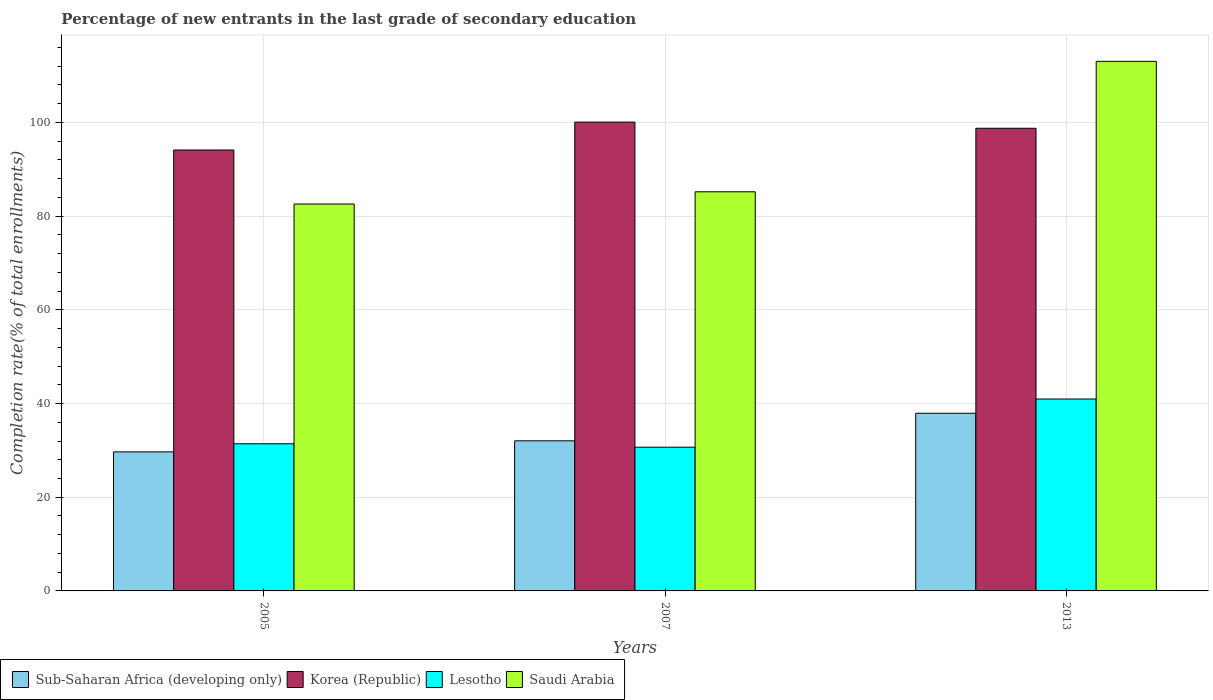Are the number of bars on each tick of the X-axis equal?
Offer a very short reply. Yes. How many bars are there on the 3rd tick from the right?
Provide a succinct answer. 4. What is the label of the 1st group of bars from the left?
Offer a terse response. 2005. In how many cases, is the number of bars for a given year not equal to the number of legend labels?
Give a very brief answer. 0. What is the percentage of new entrants in Korea (Republic) in 2013?
Offer a terse response. 98.75. Across all years, what is the maximum percentage of new entrants in Saudi Arabia?
Offer a terse response. 113.04. Across all years, what is the minimum percentage of new entrants in Korea (Republic)?
Give a very brief answer. 94.12. In which year was the percentage of new entrants in Sub-Saharan Africa (developing only) maximum?
Your response must be concise. 2013. In which year was the percentage of new entrants in Lesotho minimum?
Provide a succinct answer. 2007. What is the total percentage of new entrants in Saudi Arabia in the graph?
Your answer should be very brief. 280.83. What is the difference between the percentage of new entrants in Lesotho in 2005 and that in 2013?
Your answer should be compact. -9.56. What is the difference between the percentage of new entrants in Lesotho in 2007 and the percentage of new entrants in Korea (Republic) in 2013?
Your answer should be very brief. -68.07. What is the average percentage of new entrants in Lesotho per year?
Keep it short and to the point. 34.35. In the year 2005, what is the difference between the percentage of new entrants in Korea (Republic) and percentage of new entrants in Sub-Saharan Africa (developing only)?
Your response must be concise. 64.44. What is the ratio of the percentage of new entrants in Lesotho in 2007 to that in 2013?
Make the answer very short. 0.75. Is the percentage of new entrants in Saudi Arabia in 2007 less than that in 2013?
Offer a very short reply. Yes. What is the difference between the highest and the second highest percentage of new entrants in Sub-Saharan Africa (developing only)?
Your answer should be compact. 5.88. What is the difference between the highest and the lowest percentage of new entrants in Saudi Arabia?
Make the answer very short. 30.45. In how many years, is the percentage of new entrants in Lesotho greater than the average percentage of new entrants in Lesotho taken over all years?
Offer a terse response. 1. Is the sum of the percentage of new entrants in Sub-Saharan Africa (developing only) in 2005 and 2013 greater than the maximum percentage of new entrants in Lesotho across all years?
Ensure brevity in your answer.  Yes. Is it the case that in every year, the sum of the percentage of new entrants in Korea (Republic) and percentage of new entrants in Lesotho is greater than the sum of percentage of new entrants in Sub-Saharan Africa (developing only) and percentage of new entrants in Saudi Arabia?
Provide a short and direct response. Yes. What does the 4th bar from the right in 2013 represents?
Ensure brevity in your answer.  Sub-Saharan Africa (developing only). How many bars are there?
Your response must be concise. 12. Are all the bars in the graph horizontal?
Ensure brevity in your answer.  No. How many years are there in the graph?
Your answer should be very brief. 3. What is the difference between two consecutive major ticks on the Y-axis?
Offer a very short reply. 20. Are the values on the major ticks of Y-axis written in scientific E-notation?
Offer a terse response. No. Does the graph contain grids?
Ensure brevity in your answer.  Yes. Where does the legend appear in the graph?
Provide a succinct answer. Bottom left. What is the title of the graph?
Your answer should be compact. Percentage of new entrants in the last grade of secondary education. What is the label or title of the Y-axis?
Offer a terse response. Completion rate(% of total enrollments). What is the Completion rate(% of total enrollments) of Sub-Saharan Africa (developing only) in 2005?
Provide a short and direct response. 29.68. What is the Completion rate(% of total enrollments) in Korea (Republic) in 2005?
Offer a very short reply. 94.12. What is the Completion rate(% of total enrollments) in Lesotho in 2005?
Give a very brief answer. 31.41. What is the Completion rate(% of total enrollments) in Saudi Arabia in 2005?
Your answer should be very brief. 82.59. What is the Completion rate(% of total enrollments) of Sub-Saharan Africa (developing only) in 2007?
Provide a short and direct response. 32.04. What is the Completion rate(% of total enrollments) in Korea (Republic) in 2007?
Your response must be concise. 100.07. What is the Completion rate(% of total enrollments) of Lesotho in 2007?
Provide a short and direct response. 30.68. What is the Completion rate(% of total enrollments) in Saudi Arabia in 2007?
Offer a terse response. 85.2. What is the Completion rate(% of total enrollments) of Sub-Saharan Africa (developing only) in 2013?
Provide a succinct answer. 37.92. What is the Completion rate(% of total enrollments) of Korea (Republic) in 2013?
Give a very brief answer. 98.75. What is the Completion rate(% of total enrollments) in Lesotho in 2013?
Keep it short and to the point. 40.97. What is the Completion rate(% of total enrollments) in Saudi Arabia in 2013?
Provide a succinct answer. 113.04. Across all years, what is the maximum Completion rate(% of total enrollments) in Sub-Saharan Africa (developing only)?
Your answer should be compact. 37.92. Across all years, what is the maximum Completion rate(% of total enrollments) in Korea (Republic)?
Your answer should be very brief. 100.07. Across all years, what is the maximum Completion rate(% of total enrollments) of Lesotho?
Your answer should be very brief. 40.97. Across all years, what is the maximum Completion rate(% of total enrollments) of Saudi Arabia?
Offer a terse response. 113.04. Across all years, what is the minimum Completion rate(% of total enrollments) of Sub-Saharan Africa (developing only)?
Your answer should be compact. 29.68. Across all years, what is the minimum Completion rate(% of total enrollments) of Korea (Republic)?
Keep it short and to the point. 94.12. Across all years, what is the minimum Completion rate(% of total enrollments) in Lesotho?
Offer a terse response. 30.68. Across all years, what is the minimum Completion rate(% of total enrollments) in Saudi Arabia?
Keep it short and to the point. 82.59. What is the total Completion rate(% of total enrollments) of Sub-Saharan Africa (developing only) in the graph?
Your response must be concise. 99.64. What is the total Completion rate(% of total enrollments) in Korea (Republic) in the graph?
Offer a terse response. 292.94. What is the total Completion rate(% of total enrollments) in Lesotho in the graph?
Your answer should be very brief. 103.06. What is the total Completion rate(% of total enrollments) in Saudi Arabia in the graph?
Make the answer very short. 280.83. What is the difference between the Completion rate(% of total enrollments) of Sub-Saharan Africa (developing only) in 2005 and that in 2007?
Make the answer very short. -2.36. What is the difference between the Completion rate(% of total enrollments) of Korea (Republic) in 2005 and that in 2007?
Provide a short and direct response. -5.96. What is the difference between the Completion rate(% of total enrollments) in Lesotho in 2005 and that in 2007?
Your answer should be very brief. 0.73. What is the difference between the Completion rate(% of total enrollments) of Saudi Arabia in 2005 and that in 2007?
Your answer should be compact. -2.61. What is the difference between the Completion rate(% of total enrollments) in Sub-Saharan Africa (developing only) in 2005 and that in 2013?
Ensure brevity in your answer.  -8.25. What is the difference between the Completion rate(% of total enrollments) of Korea (Republic) in 2005 and that in 2013?
Make the answer very short. -4.64. What is the difference between the Completion rate(% of total enrollments) in Lesotho in 2005 and that in 2013?
Your answer should be very brief. -9.56. What is the difference between the Completion rate(% of total enrollments) in Saudi Arabia in 2005 and that in 2013?
Your answer should be very brief. -30.45. What is the difference between the Completion rate(% of total enrollments) in Sub-Saharan Africa (developing only) in 2007 and that in 2013?
Offer a very short reply. -5.88. What is the difference between the Completion rate(% of total enrollments) of Korea (Republic) in 2007 and that in 2013?
Your answer should be very brief. 1.32. What is the difference between the Completion rate(% of total enrollments) in Lesotho in 2007 and that in 2013?
Keep it short and to the point. -10.29. What is the difference between the Completion rate(% of total enrollments) of Saudi Arabia in 2007 and that in 2013?
Offer a terse response. -27.84. What is the difference between the Completion rate(% of total enrollments) of Sub-Saharan Africa (developing only) in 2005 and the Completion rate(% of total enrollments) of Korea (Republic) in 2007?
Make the answer very short. -70.4. What is the difference between the Completion rate(% of total enrollments) in Sub-Saharan Africa (developing only) in 2005 and the Completion rate(% of total enrollments) in Lesotho in 2007?
Your answer should be compact. -1. What is the difference between the Completion rate(% of total enrollments) in Sub-Saharan Africa (developing only) in 2005 and the Completion rate(% of total enrollments) in Saudi Arabia in 2007?
Offer a terse response. -55.52. What is the difference between the Completion rate(% of total enrollments) in Korea (Republic) in 2005 and the Completion rate(% of total enrollments) in Lesotho in 2007?
Offer a terse response. 63.44. What is the difference between the Completion rate(% of total enrollments) in Korea (Republic) in 2005 and the Completion rate(% of total enrollments) in Saudi Arabia in 2007?
Provide a succinct answer. 8.92. What is the difference between the Completion rate(% of total enrollments) of Lesotho in 2005 and the Completion rate(% of total enrollments) of Saudi Arabia in 2007?
Ensure brevity in your answer.  -53.79. What is the difference between the Completion rate(% of total enrollments) in Sub-Saharan Africa (developing only) in 2005 and the Completion rate(% of total enrollments) in Korea (Republic) in 2013?
Offer a very short reply. -69.08. What is the difference between the Completion rate(% of total enrollments) of Sub-Saharan Africa (developing only) in 2005 and the Completion rate(% of total enrollments) of Lesotho in 2013?
Ensure brevity in your answer.  -11.29. What is the difference between the Completion rate(% of total enrollments) in Sub-Saharan Africa (developing only) in 2005 and the Completion rate(% of total enrollments) in Saudi Arabia in 2013?
Offer a terse response. -83.36. What is the difference between the Completion rate(% of total enrollments) of Korea (Republic) in 2005 and the Completion rate(% of total enrollments) of Lesotho in 2013?
Ensure brevity in your answer.  53.15. What is the difference between the Completion rate(% of total enrollments) of Korea (Republic) in 2005 and the Completion rate(% of total enrollments) of Saudi Arabia in 2013?
Offer a very short reply. -18.92. What is the difference between the Completion rate(% of total enrollments) of Lesotho in 2005 and the Completion rate(% of total enrollments) of Saudi Arabia in 2013?
Provide a short and direct response. -81.63. What is the difference between the Completion rate(% of total enrollments) of Sub-Saharan Africa (developing only) in 2007 and the Completion rate(% of total enrollments) of Korea (Republic) in 2013?
Make the answer very short. -66.72. What is the difference between the Completion rate(% of total enrollments) of Sub-Saharan Africa (developing only) in 2007 and the Completion rate(% of total enrollments) of Lesotho in 2013?
Provide a short and direct response. -8.93. What is the difference between the Completion rate(% of total enrollments) of Sub-Saharan Africa (developing only) in 2007 and the Completion rate(% of total enrollments) of Saudi Arabia in 2013?
Your response must be concise. -81. What is the difference between the Completion rate(% of total enrollments) in Korea (Republic) in 2007 and the Completion rate(% of total enrollments) in Lesotho in 2013?
Make the answer very short. 59.11. What is the difference between the Completion rate(% of total enrollments) of Korea (Republic) in 2007 and the Completion rate(% of total enrollments) of Saudi Arabia in 2013?
Offer a very short reply. -12.97. What is the difference between the Completion rate(% of total enrollments) of Lesotho in 2007 and the Completion rate(% of total enrollments) of Saudi Arabia in 2013?
Provide a succinct answer. -82.36. What is the average Completion rate(% of total enrollments) in Sub-Saharan Africa (developing only) per year?
Offer a very short reply. 33.21. What is the average Completion rate(% of total enrollments) of Korea (Republic) per year?
Make the answer very short. 97.65. What is the average Completion rate(% of total enrollments) in Lesotho per year?
Offer a terse response. 34.35. What is the average Completion rate(% of total enrollments) of Saudi Arabia per year?
Offer a very short reply. 93.61. In the year 2005, what is the difference between the Completion rate(% of total enrollments) of Sub-Saharan Africa (developing only) and Completion rate(% of total enrollments) of Korea (Republic)?
Offer a very short reply. -64.44. In the year 2005, what is the difference between the Completion rate(% of total enrollments) of Sub-Saharan Africa (developing only) and Completion rate(% of total enrollments) of Lesotho?
Your answer should be very brief. -1.73. In the year 2005, what is the difference between the Completion rate(% of total enrollments) in Sub-Saharan Africa (developing only) and Completion rate(% of total enrollments) in Saudi Arabia?
Provide a short and direct response. -52.91. In the year 2005, what is the difference between the Completion rate(% of total enrollments) in Korea (Republic) and Completion rate(% of total enrollments) in Lesotho?
Your answer should be compact. 62.71. In the year 2005, what is the difference between the Completion rate(% of total enrollments) in Korea (Republic) and Completion rate(% of total enrollments) in Saudi Arabia?
Ensure brevity in your answer.  11.53. In the year 2005, what is the difference between the Completion rate(% of total enrollments) of Lesotho and Completion rate(% of total enrollments) of Saudi Arabia?
Your answer should be very brief. -51.18. In the year 2007, what is the difference between the Completion rate(% of total enrollments) of Sub-Saharan Africa (developing only) and Completion rate(% of total enrollments) of Korea (Republic)?
Your answer should be compact. -68.03. In the year 2007, what is the difference between the Completion rate(% of total enrollments) of Sub-Saharan Africa (developing only) and Completion rate(% of total enrollments) of Lesotho?
Your answer should be compact. 1.36. In the year 2007, what is the difference between the Completion rate(% of total enrollments) in Sub-Saharan Africa (developing only) and Completion rate(% of total enrollments) in Saudi Arabia?
Make the answer very short. -53.16. In the year 2007, what is the difference between the Completion rate(% of total enrollments) of Korea (Republic) and Completion rate(% of total enrollments) of Lesotho?
Provide a short and direct response. 69.39. In the year 2007, what is the difference between the Completion rate(% of total enrollments) of Korea (Republic) and Completion rate(% of total enrollments) of Saudi Arabia?
Provide a succinct answer. 14.87. In the year 2007, what is the difference between the Completion rate(% of total enrollments) in Lesotho and Completion rate(% of total enrollments) in Saudi Arabia?
Ensure brevity in your answer.  -54.52. In the year 2013, what is the difference between the Completion rate(% of total enrollments) of Sub-Saharan Africa (developing only) and Completion rate(% of total enrollments) of Korea (Republic)?
Ensure brevity in your answer.  -60.83. In the year 2013, what is the difference between the Completion rate(% of total enrollments) of Sub-Saharan Africa (developing only) and Completion rate(% of total enrollments) of Lesotho?
Your answer should be compact. -3.04. In the year 2013, what is the difference between the Completion rate(% of total enrollments) of Sub-Saharan Africa (developing only) and Completion rate(% of total enrollments) of Saudi Arabia?
Give a very brief answer. -75.12. In the year 2013, what is the difference between the Completion rate(% of total enrollments) of Korea (Republic) and Completion rate(% of total enrollments) of Lesotho?
Offer a terse response. 57.79. In the year 2013, what is the difference between the Completion rate(% of total enrollments) of Korea (Republic) and Completion rate(% of total enrollments) of Saudi Arabia?
Offer a terse response. -14.29. In the year 2013, what is the difference between the Completion rate(% of total enrollments) of Lesotho and Completion rate(% of total enrollments) of Saudi Arabia?
Your response must be concise. -72.07. What is the ratio of the Completion rate(% of total enrollments) in Sub-Saharan Africa (developing only) in 2005 to that in 2007?
Provide a succinct answer. 0.93. What is the ratio of the Completion rate(% of total enrollments) of Korea (Republic) in 2005 to that in 2007?
Your response must be concise. 0.94. What is the ratio of the Completion rate(% of total enrollments) of Lesotho in 2005 to that in 2007?
Offer a terse response. 1.02. What is the ratio of the Completion rate(% of total enrollments) of Saudi Arabia in 2005 to that in 2007?
Your answer should be very brief. 0.97. What is the ratio of the Completion rate(% of total enrollments) in Sub-Saharan Africa (developing only) in 2005 to that in 2013?
Provide a succinct answer. 0.78. What is the ratio of the Completion rate(% of total enrollments) in Korea (Republic) in 2005 to that in 2013?
Your response must be concise. 0.95. What is the ratio of the Completion rate(% of total enrollments) in Lesotho in 2005 to that in 2013?
Your answer should be compact. 0.77. What is the ratio of the Completion rate(% of total enrollments) of Saudi Arabia in 2005 to that in 2013?
Make the answer very short. 0.73. What is the ratio of the Completion rate(% of total enrollments) of Sub-Saharan Africa (developing only) in 2007 to that in 2013?
Ensure brevity in your answer.  0.84. What is the ratio of the Completion rate(% of total enrollments) in Korea (Republic) in 2007 to that in 2013?
Offer a very short reply. 1.01. What is the ratio of the Completion rate(% of total enrollments) in Lesotho in 2007 to that in 2013?
Offer a terse response. 0.75. What is the ratio of the Completion rate(% of total enrollments) of Saudi Arabia in 2007 to that in 2013?
Offer a terse response. 0.75. What is the difference between the highest and the second highest Completion rate(% of total enrollments) of Sub-Saharan Africa (developing only)?
Your answer should be very brief. 5.88. What is the difference between the highest and the second highest Completion rate(% of total enrollments) of Korea (Republic)?
Offer a very short reply. 1.32. What is the difference between the highest and the second highest Completion rate(% of total enrollments) in Lesotho?
Your response must be concise. 9.56. What is the difference between the highest and the second highest Completion rate(% of total enrollments) in Saudi Arabia?
Your response must be concise. 27.84. What is the difference between the highest and the lowest Completion rate(% of total enrollments) in Sub-Saharan Africa (developing only)?
Make the answer very short. 8.25. What is the difference between the highest and the lowest Completion rate(% of total enrollments) of Korea (Republic)?
Make the answer very short. 5.96. What is the difference between the highest and the lowest Completion rate(% of total enrollments) in Lesotho?
Ensure brevity in your answer.  10.29. What is the difference between the highest and the lowest Completion rate(% of total enrollments) of Saudi Arabia?
Ensure brevity in your answer.  30.45. 